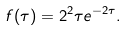Convert formula to latex. <formula><loc_0><loc_0><loc_500><loc_500>f ( \tau ) = 2 ^ { 2 } \tau e ^ { - 2 \tau } .</formula> 